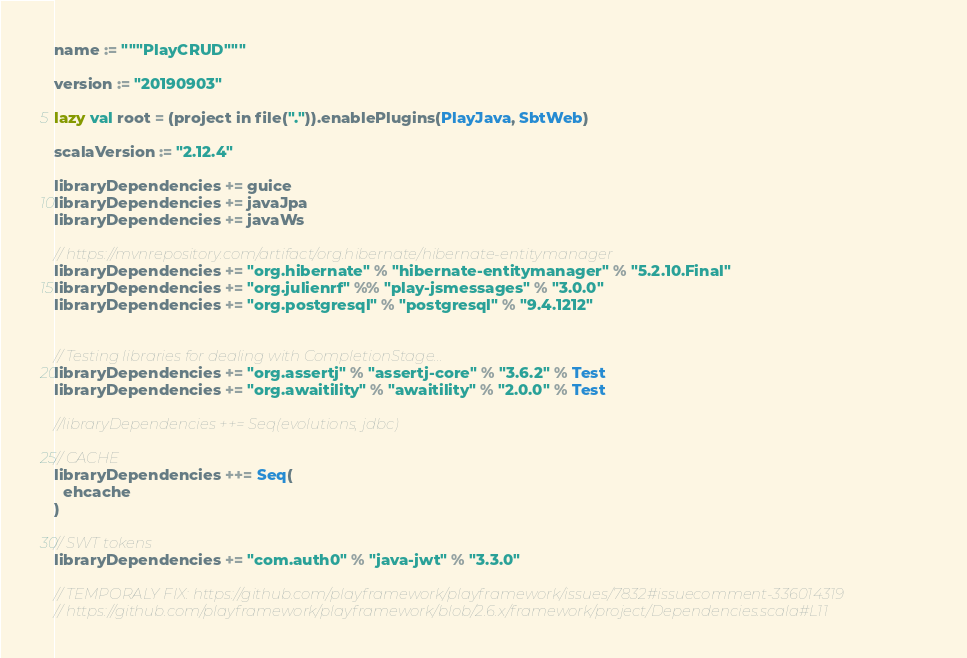<code> <loc_0><loc_0><loc_500><loc_500><_Scala_>name := """PlayCRUD"""

version := "20190903"

lazy val root = (project in file(".")).enablePlugins(PlayJava, SbtWeb)

scalaVersion := "2.12.4"

libraryDependencies += guice
libraryDependencies += javaJpa
libraryDependencies += javaWs

// https://mvnrepository.com/artifact/org.hibernate/hibernate-entitymanager
libraryDependencies += "org.hibernate" % "hibernate-entitymanager" % "5.2.10.Final"
libraryDependencies += "org.julienrf" %% "play-jsmessages" % "3.0.0"
libraryDependencies += "org.postgresql" % "postgresql" % "9.4.1212"


// Testing libraries for dealing with CompletionStage...
libraryDependencies += "org.assertj" % "assertj-core" % "3.6.2" % Test
libraryDependencies += "org.awaitility" % "awaitility" % "2.0.0" % Test

//libraryDependencies ++= Seq(evolutions, jdbc)

// CACHE
libraryDependencies ++= Seq(
  ehcache
)

// SWT tokens
libraryDependencies += "com.auth0" % "java-jwt" % "3.3.0"

// TEMPORALY FIX: https://github.com/playframework/playframework/issues/7832#issuecomment-336014319
// https://github.com/playframework/playframework/blob/2.6.x/framework/project/Dependencies.scala#L11</code> 